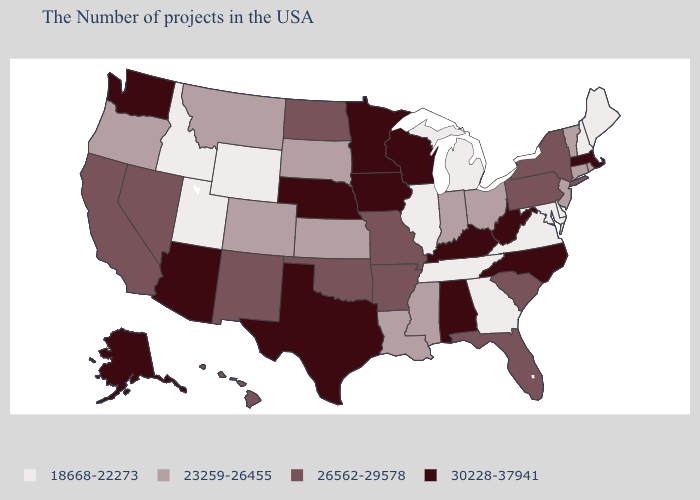Which states have the lowest value in the West?
Answer briefly. Wyoming, Utah, Idaho. What is the lowest value in states that border Maryland?
Give a very brief answer. 18668-22273. Does Minnesota have the highest value in the MidWest?
Quick response, please. Yes. What is the value of Tennessee?
Keep it brief. 18668-22273. What is the highest value in the Northeast ?
Keep it brief. 30228-37941. What is the value of Texas?
Answer briefly. 30228-37941. Among the states that border South Dakota , which have the highest value?
Quick response, please. Minnesota, Iowa, Nebraska. Is the legend a continuous bar?
Give a very brief answer. No. What is the highest value in states that border Utah?
Concise answer only. 30228-37941. What is the highest value in states that border Arizona?
Concise answer only. 26562-29578. Name the states that have a value in the range 30228-37941?
Write a very short answer. Massachusetts, North Carolina, West Virginia, Kentucky, Alabama, Wisconsin, Minnesota, Iowa, Nebraska, Texas, Arizona, Washington, Alaska. What is the value of Rhode Island?
Give a very brief answer. 23259-26455. What is the lowest value in the USA?
Give a very brief answer. 18668-22273. Does the first symbol in the legend represent the smallest category?
Be succinct. Yes. Name the states that have a value in the range 30228-37941?
Keep it brief. Massachusetts, North Carolina, West Virginia, Kentucky, Alabama, Wisconsin, Minnesota, Iowa, Nebraska, Texas, Arizona, Washington, Alaska. 